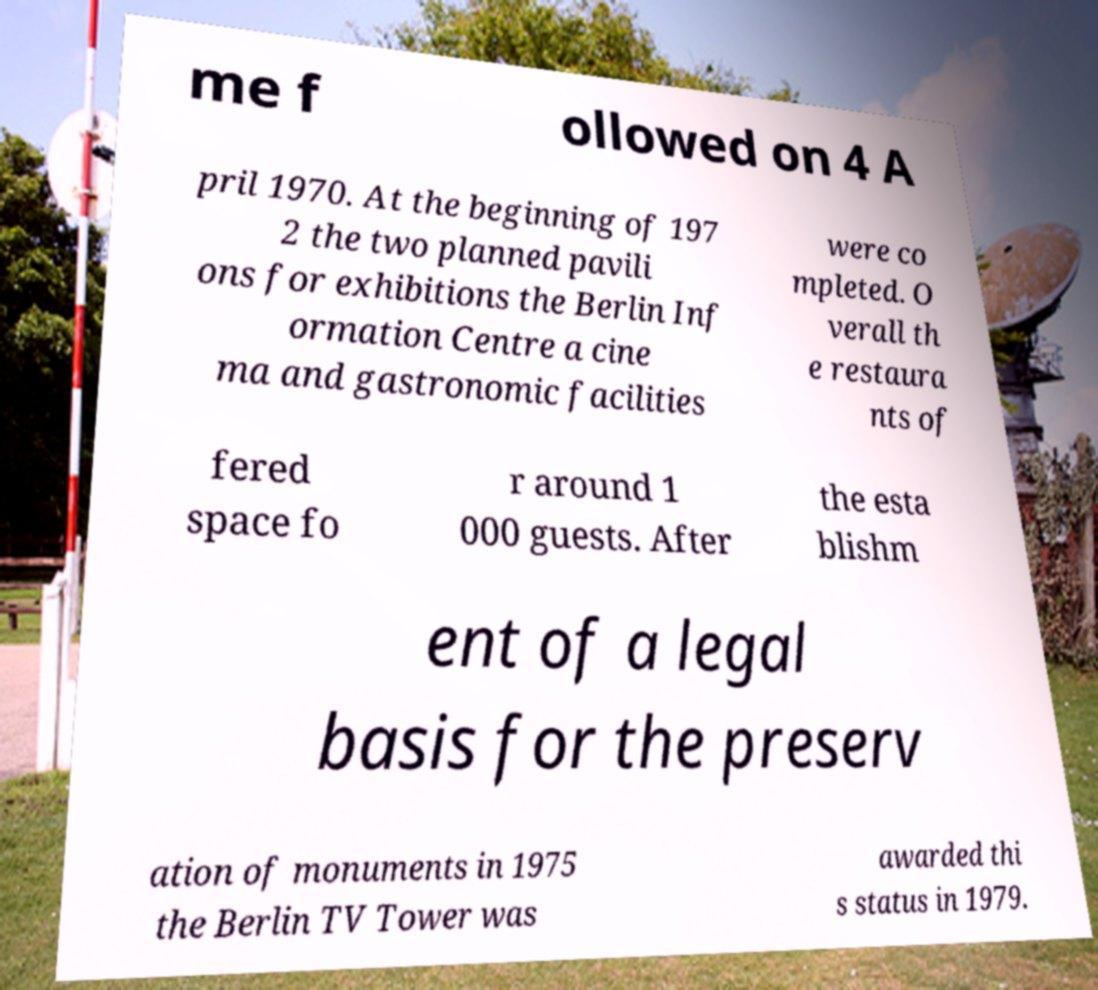What messages or text are displayed in this image? I need them in a readable, typed format. me f ollowed on 4 A pril 1970. At the beginning of 197 2 the two planned pavili ons for exhibitions the Berlin Inf ormation Centre a cine ma and gastronomic facilities were co mpleted. O verall th e restaura nts of fered space fo r around 1 000 guests. After the esta blishm ent of a legal basis for the preserv ation of monuments in 1975 the Berlin TV Tower was awarded thi s status in 1979. 